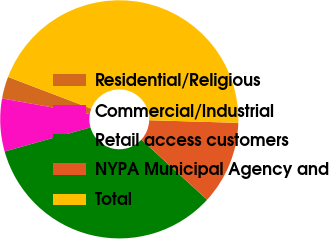Convert chart. <chart><loc_0><loc_0><loc_500><loc_500><pie_chart><fcel>Residential/Religious<fcel>Commercial/Industrial<fcel>Retail access customers<fcel>NYPA Municipal Agency and<fcel>Total<nl><fcel>2.99%<fcel>7.16%<fcel>33.85%<fcel>11.33%<fcel>44.67%<nl></chart> 